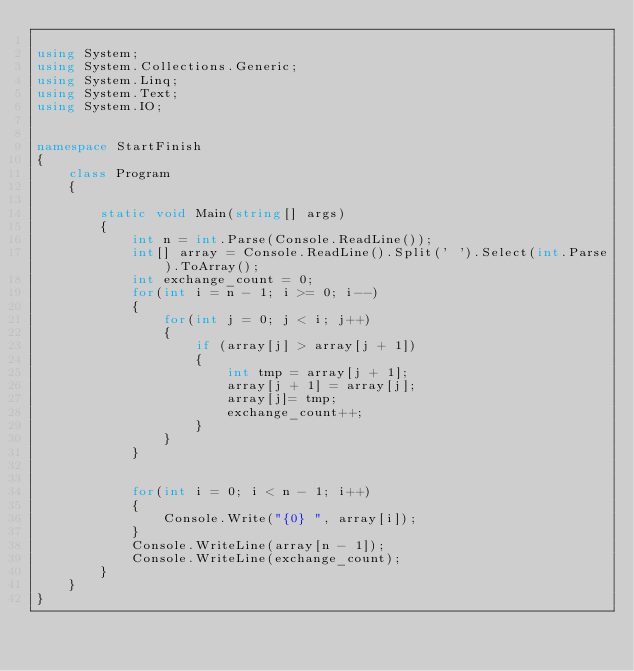<code> <loc_0><loc_0><loc_500><loc_500><_C#_>
using System;
using System.Collections.Generic;
using System.Linq;
using System.Text;
using System.IO;


namespace StartFinish
{
    class Program
    {   
            
        static void Main(string[] args)
        {
            int n = int.Parse(Console.ReadLine());
            int[] array = Console.ReadLine().Split(' ').Select(int.Parse).ToArray();
            int exchange_count = 0;
            for(int i = n - 1; i >= 0; i--)
            {
                for(int j = 0; j < i; j++)
                {
                    if (array[j] > array[j + 1])
                    {
                        int tmp = array[j + 1];
                        array[j + 1] = array[j];
                        array[j]= tmp;
                        exchange_count++;
                    }
                }
            }


            for(int i = 0; i < n - 1; i++)
            {
                Console.Write("{0} ", array[i]);
            }
            Console.WriteLine(array[n - 1]);
            Console.WriteLine(exchange_count);
        }
    }
}</code> 